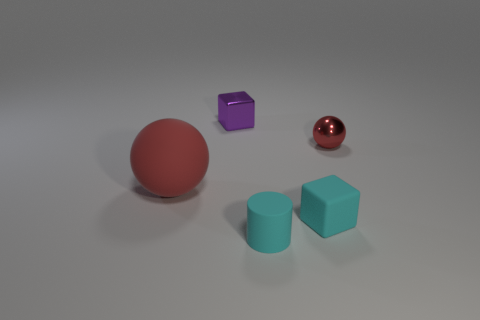Does the small red metallic object have the same shape as the large matte object?
Offer a terse response. Yes. What number of tiny cylinders are the same color as the small sphere?
Your answer should be very brief. 0. How many objects are either rubber things to the right of the purple thing or tiny cyan matte objects?
Your answer should be compact. 2. There is a ball that is in front of the tiny ball; what size is it?
Ensure brevity in your answer.  Large. Are there fewer large purple things than tiny cyan cylinders?
Your answer should be compact. Yes. Does the cube that is on the right side of the purple shiny block have the same material as the ball to the left of the tiny rubber cylinder?
Offer a very short reply. Yes. What shape is the rubber object that is to the left of the small block that is behind the red rubber sphere on the left side of the tiny rubber cylinder?
Make the answer very short. Sphere. How many cyan things are the same material as the tiny cyan block?
Give a very brief answer. 1. There is a small block that is behind the small sphere; how many balls are right of it?
Provide a short and direct response. 1. Do the tiny cube in front of the tiny metallic sphere and the tiny object that is in front of the small matte block have the same color?
Ensure brevity in your answer.  Yes. 